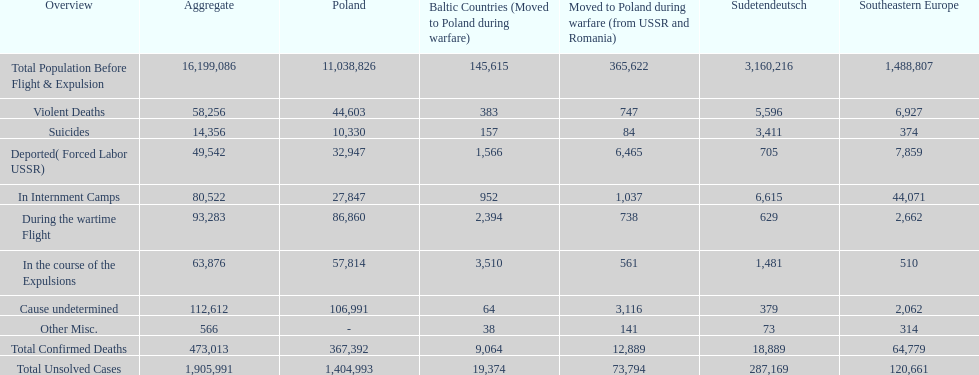What is the overall number of fatalities in detention centers and throughout the wartime escape? 173,805. 